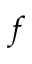<formula> <loc_0><loc_0><loc_500><loc_500>f</formula> 